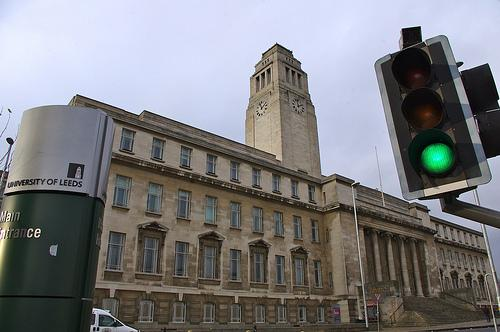Mention the most striking elements in the scene displayed in the image. The image highlights the clock tower at the University of Leeds, a lit green traffic light, and a parked white vehicle.  Provide a brief description of the primary focus in the image. A clock tower at the University of Leeds with a lit green traffic light and a white vehicle parked nearby. Summarize the key points of the image in your own words. In the image, a prominent clock tower is seen at the University of Leeds, along with a green traffic light and a white vehicle. What aspects of the image stand out to you the most? The clock tower, green traffic light, and the white vehicle. What would a viewer first notice when looking at the image? The viewer might first notice the clock tower, green traffic light, and the white vehicle. In one sentence, describe the main structures in the image. The image features a clock tower, a building with several windows, and a sign at the University of Leeds. Write a simple sentence describing the contents of the picture. There is a clock tower, green traffic light, and a white vehicle in the image. Briefly describe what someone might think when they first glance at the image. Upon first glance, the clock tower, green traffic light, and the white vehicle might catch the viewer's eye. State the main components in the image using an expressive sentence. The skillfully crafted clock tower stands tall amidst the bustling scene, with a green light ushering in a sense of harmony as a pristine white vehicle waits nearby. List the primary objects that feature in the image. Clock tower, green traffic light, white vehicle, building, and sign. 